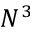Convert formula to latex. <formula><loc_0><loc_0><loc_500><loc_500>N ^ { 3 }</formula> 